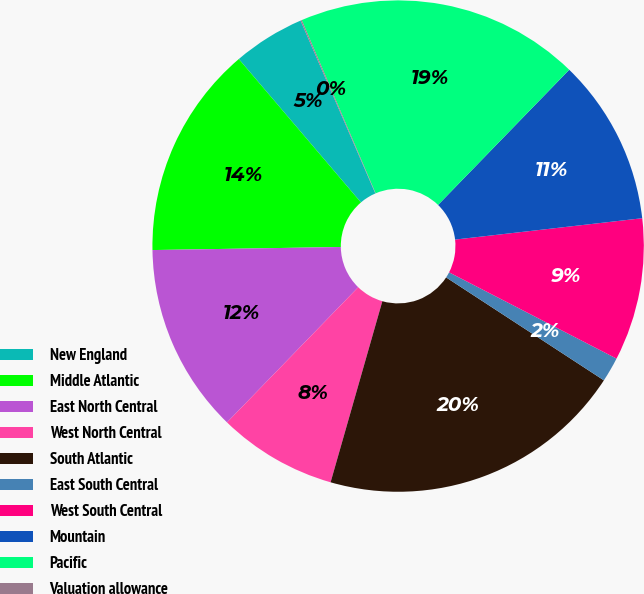<chart> <loc_0><loc_0><loc_500><loc_500><pie_chart><fcel>New England<fcel>Middle Atlantic<fcel>East North Central<fcel>West North Central<fcel>South Atlantic<fcel>East South Central<fcel>West South Central<fcel>Mountain<fcel>Pacific<fcel>Valuation allowance<nl><fcel>4.73%<fcel>14.03%<fcel>12.48%<fcel>7.83%<fcel>20.23%<fcel>1.63%<fcel>9.38%<fcel>10.93%<fcel>18.68%<fcel>0.08%<nl></chart> 